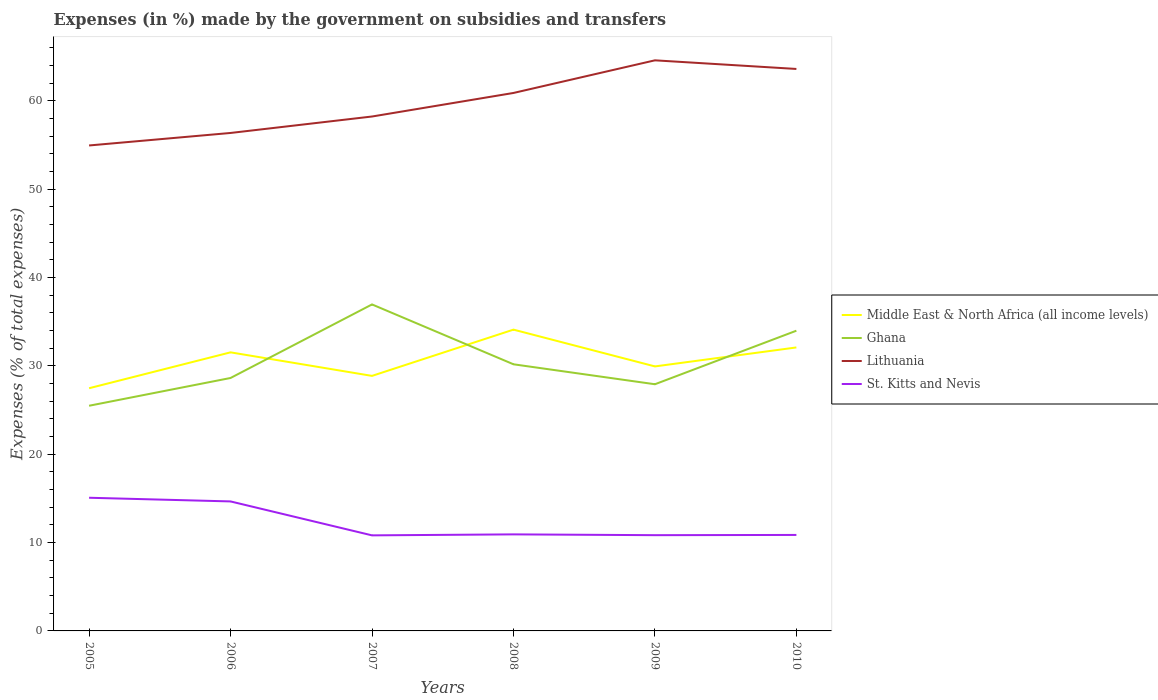Does the line corresponding to Lithuania intersect with the line corresponding to St. Kitts and Nevis?
Make the answer very short. No. Across all years, what is the maximum percentage of expenses made by the government on subsidies and transfers in St. Kitts and Nevis?
Keep it short and to the point. 10.82. What is the total percentage of expenses made by the government on subsidies and transfers in Middle East & North Africa (all income levels) in the graph?
Provide a short and direct response. -4.62. What is the difference between the highest and the second highest percentage of expenses made by the government on subsidies and transfers in Lithuania?
Your answer should be compact. 9.64. What is the difference between the highest and the lowest percentage of expenses made by the government on subsidies and transfers in Ghana?
Ensure brevity in your answer.  2. Is the percentage of expenses made by the government on subsidies and transfers in Middle East & North Africa (all income levels) strictly greater than the percentage of expenses made by the government on subsidies and transfers in Ghana over the years?
Provide a short and direct response. No. How many years are there in the graph?
Provide a succinct answer. 6. What is the difference between two consecutive major ticks on the Y-axis?
Your answer should be compact. 10. Does the graph contain any zero values?
Provide a succinct answer. No. Where does the legend appear in the graph?
Provide a succinct answer. Center right. What is the title of the graph?
Ensure brevity in your answer.  Expenses (in %) made by the government on subsidies and transfers. What is the label or title of the Y-axis?
Offer a terse response. Expenses (% of total expenses). What is the Expenses (% of total expenses) of Middle East & North Africa (all income levels) in 2005?
Your answer should be very brief. 27.47. What is the Expenses (% of total expenses) in Ghana in 2005?
Offer a terse response. 25.49. What is the Expenses (% of total expenses) in Lithuania in 2005?
Your response must be concise. 54.96. What is the Expenses (% of total expenses) of St. Kitts and Nevis in 2005?
Provide a short and direct response. 15.08. What is the Expenses (% of total expenses) in Middle East & North Africa (all income levels) in 2006?
Provide a short and direct response. 31.54. What is the Expenses (% of total expenses) of Ghana in 2006?
Your answer should be very brief. 28.63. What is the Expenses (% of total expenses) in Lithuania in 2006?
Keep it short and to the point. 56.37. What is the Expenses (% of total expenses) in St. Kitts and Nevis in 2006?
Keep it short and to the point. 14.66. What is the Expenses (% of total expenses) of Middle East & North Africa (all income levels) in 2007?
Your answer should be very brief. 28.87. What is the Expenses (% of total expenses) in Ghana in 2007?
Ensure brevity in your answer.  36.96. What is the Expenses (% of total expenses) in Lithuania in 2007?
Offer a very short reply. 58.23. What is the Expenses (% of total expenses) in St. Kitts and Nevis in 2007?
Provide a short and direct response. 10.82. What is the Expenses (% of total expenses) in Middle East & North Africa (all income levels) in 2008?
Your answer should be very brief. 34.11. What is the Expenses (% of total expenses) in Ghana in 2008?
Offer a terse response. 30.18. What is the Expenses (% of total expenses) in Lithuania in 2008?
Your answer should be very brief. 60.9. What is the Expenses (% of total expenses) in St. Kitts and Nevis in 2008?
Make the answer very short. 10.93. What is the Expenses (% of total expenses) in Middle East & North Africa (all income levels) in 2009?
Your answer should be very brief. 29.94. What is the Expenses (% of total expenses) of Ghana in 2009?
Ensure brevity in your answer.  27.92. What is the Expenses (% of total expenses) in Lithuania in 2009?
Your answer should be very brief. 64.59. What is the Expenses (% of total expenses) in St. Kitts and Nevis in 2009?
Offer a very short reply. 10.84. What is the Expenses (% of total expenses) of Middle East & North Africa (all income levels) in 2010?
Provide a succinct answer. 32.09. What is the Expenses (% of total expenses) in Ghana in 2010?
Provide a short and direct response. 33.99. What is the Expenses (% of total expenses) of Lithuania in 2010?
Offer a terse response. 63.62. What is the Expenses (% of total expenses) of St. Kitts and Nevis in 2010?
Give a very brief answer. 10.87. Across all years, what is the maximum Expenses (% of total expenses) in Middle East & North Africa (all income levels)?
Make the answer very short. 34.11. Across all years, what is the maximum Expenses (% of total expenses) of Ghana?
Your answer should be compact. 36.96. Across all years, what is the maximum Expenses (% of total expenses) of Lithuania?
Your response must be concise. 64.59. Across all years, what is the maximum Expenses (% of total expenses) of St. Kitts and Nevis?
Your answer should be very brief. 15.08. Across all years, what is the minimum Expenses (% of total expenses) of Middle East & North Africa (all income levels)?
Your response must be concise. 27.47. Across all years, what is the minimum Expenses (% of total expenses) in Ghana?
Give a very brief answer. 25.49. Across all years, what is the minimum Expenses (% of total expenses) of Lithuania?
Ensure brevity in your answer.  54.96. Across all years, what is the minimum Expenses (% of total expenses) of St. Kitts and Nevis?
Your answer should be compact. 10.82. What is the total Expenses (% of total expenses) in Middle East & North Africa (all income levels) in the graph?
Provide a succinct answer. 184.02. What is the total Expenses (% of total expenses) in Ghana in the graph?
Ensure brevity in your answer.  183.18. What is the total Expenses (% of total expenses) of Lithuania in the graph?
Your response must be concise. 358.67. What is the total Expenses (% of total expenses) of St. Kitts and Nevis in the graph?
Provide a succinct answer. 73.19. What is the difference between the Expenses (% of total expenses) of Middle East & North Africa (all income levels) in 2005 and that in 2006?
Keep it short and to the point. -4.06. What is the difference between the Expenses (% of total expenses) in Ghana in 2005 and that in 2006?
Offer a very short reply. -3.14. What is the difference between the Expenses (% of total expenses) of Lithuania in 2005 and that in 2006?
Make the answer very short. -1.42. What is the difference between the Expenses (% of total expenses) in St. Kitts and Nevis in 2005 and that in 2006?
Give a very brief answer. 0.42. What is the difference between the Expenses (% of total expenses) of Middle East & North Africa (all income levels) in 2005 and that in 2007?
Offer a very short reply. -1.4. What is the difference between the Expenses (% of total expenses) in Ghana in 2005 and that in 2007?
Keep it short and to the point. -11.47. What is the difference between the Expenses (% of total expenses) in Lithuania in 2005 and that in 2007?
Provide a succinct answer. -3.28. What is the difference between the Expenses (% of total expenses) of St. Kitts and Nevis in 2005 and that in 2007?
Ensure brevity in your answer.  4.26. What is the difference between the Expenses (% of total expenses) of Middle East & North Africa (all income levels) in 2005 and that in 2008?
Ensure brevity in your answer.  -6.63. What is the difference between the Expenses (% of total expenses) of Ghana in 2005 and that in 2008?
Offer a very short reply. -4.69. What is the difference between the Expenses (% of total expenses) in Lithuania in 2005 and that in 2008?
Your response must be concise. -5.94. What is the difference between the Expenses (% of total expenses) in St. Kitts and Nevis in 2005 and that in 2008?
Your response must be concise. 4.15. What is the difference between the Expenses (% of total expenses) in Middle East & North Africa (all income levels) in 2005 and that in 2009?
Ensure brevity in your answer.  -2.47. What is the difference between the Expenses (% of total expenses) of Ghana in 2005 and that in 2009?
Keep it short and to the point. -2.43. What is the difference between the Expenses (% of total expenses) of Lithuania in 2005 and that in 2009?
Ensure brevity in your answer.  -9.64. What is the difference between the Expenses (% of total expenses) of St. Kitts and Nevis in 2005 and that in 2009?
Give a very brief answer. 4.24. What is the difference between the Expenses (% of total expenses) of Middle East & North Africa (all income levels) in 2005 and that in 2010?
Keep it short and to the point. -4.62. What is the difference between the Expenses (% of total expenses) of Ghana in 2005 and that in 2010?
Give a very brief answer. -8.5. What is the difference between the Expenses (% of total expenses) in Lithuania in 2005 and that in 2010?
Keep it short and to the point. -8.66. What is the difference between the Expenses (% of total expenses) in St. Kitts and Nevis in 2005 and that in 2010?
Provide a succinct answer. 4.21. What is the difference between the Expenses (% of total expenses) of Middle East & North Africa (all income levels) in 2006 and that in 2007?
Offer a terse response. 2.67. What is the difference between the Expenses (% of total expenses) in Ghana in 2006 and that in 2007?
Give a very brief answer. -8.33. What is the difference between the Expenses (% of total expenses) of Lithuania in 2006 and that in 2007?
Ensure brevity in your answer.  -1.86. What is the difference between the Expenses (% of total expenses) of St. Kitts and Nevis in 2006 and that in 2007?
Your response must be concise. 3.84. What is the difference between the Expenses (% of total expenses) in Middle East & North Africa (all income levels) in 2006 and that in 2008?
Ensure brevity in your answer.  -2.57. What is the difference between the Expenses (% of total expenses) of Ghana in 2006 and that in 2008?
Ensure brevity in your answer.  -1.55. What is the difference between the Expenses (% of total expenses) of Lithuania in 2006 and that in 2008?
Keep it short and to the point. -4.53. What is the difference between the Expenses (% of total expenses) in St. Kitts and Nevis in 2006 and that in 2008?
Your response must be concise. 3.73. What is the difference between the Expenses (% of total expenses) of Middle East & North Africa (all income levels) in 2006 and that in 2009?
Provide a short and direct response. 1.59. What is the difference between the Expenses (% of total expenses) in Ghana in 2006 and that in 2009?
Keep it short and to the point. 0.71. What is the difference between the Expenses (% of total expenses) in Lithuania in 2006 and that in 2009?
Offer a terse response. -8.22. What is the difference between the Expenses (% of total expenses) of St. Kitts and Nevis in 2006 and that in 2009?
Ensure brevity in your answer.  3.82. What is the difference between the Expenses (% of total expenses) of Middle East & North Africa (all income levels) in 2006 and that in 2010?
Provide a short and direct response. -0.56. What is the difference between the Expenses (% of total expenses) in Ghana in 2006 and that in 2010?
Your answer should be very brief. -5.35. What is the difference between the Expenses (% of total expenses) of Lithuania in 2006 and that in 2010?
Your answer should be compact. -7.25. What is the difference between the Expenses (% of total expenses) of St. Kitts and Nevis in 2006 and that in 2010?
Your response must be concise. 3.79. What is the difference between the Expenses (% of total expenses) in Middle East & North Africa (all income levels) in 2007 and that in 2008?
Offer a terse response. -5.24. What is the difference between the Expenses (% of total expenses) in Ghana in 2007 and that in 2008?
Give a very brief answer. 6.78. What is the difference between the Expenses (% of total expenses) of Lithuania in 2007 and that in 2008?
Ensure brevity in your answer.  -2.67. What is the difference between the Expenses (% of total expenses) of St. Kitts and Nevis in 2007 and that in 2008?
Make the answer very short. -0.11. What is the difference between the Expenses (% of total expenses) of Middle East & North Africa (all income levels) in 2007 and that in 2009?
Your answer should be very brief. -1.07. What is the difference between the Expenses (% of total expenses) of Ghana in 2007 and that in 2009?
Provide a short and direct response. 9.04. What is the difference between the Expenses (% of total expenses) of Lithuania in 2007 and that in 2009?
Ensure brevity in your answer.  -6.36. What is the difference between the Expenses (% of total expenses) of St. Kitts and Nevis in 2007 and that in 2009?
Make the answer very short. -0.02. What is the difference between the Expenses (% of total expenses) in Middle East & North Africa (all income levels) in 2007 and that in 2010?
Provide a succinct answer. -3.22. What is the difference between the Expenses (% of total expenses) of Ghana in 2007 and that in 2010?
Provide a short and direct response. 2.97. What is the difference between the Expenses (% of total expenses) in Lithuania in 2007 and that in 2010?
Your response must be concise. -5.38. What is the difference between the Expenses (% of total expenses) of St. Kitts and Nevis in 2007 and that in 2010?
Ensure brevity in your answer.  -0.05. What is the difference between the Expenses (% of total expenses) in Middle East & North Africa (all income levels) in 2008 and that in 2009?
Ensure brevity in your answer.  4.16. What is the difference between the Expenses (% of total expenses) of Ghana in 2008 and that in 2009?
Your answer should be compact. 2.26. What is the difference between the Expenses (% of total expenses) of Lithuania in 2008 and that in 2009?
Offer a very short reply. -3.69. What is the difference between the Expenses (% of total expenses) of St. Kitts and Nevis in 2008 and that in 2009?
Your response must be concise. 0.09. What is the difference between the Expenses (% of total expenses) of Middle East & North Africa (all income levels) in 2008 and that in 2010?
Your response must be concise. 2.02. What is the difference between the Expenses (% of total expenses) of Ghana in 2008 and that in 2010?
Provide a succinct answer. -3.8. What is the difference between the Expenses (% of total expenses) of Lithuania in 2008 and that in 2010?
Your answer should be very brief. -2.72. What is the difference between the Expenses (% of total expenses) in St. Kitts and Nevis in 2008 and that in 2010?
Your answer should be very brief. 0.06. What is the difference between the Expenses (% of total expenses) of Middle East & North Africa (all income levels) in 2009 and that in 2010?
Offer a terse response. -2.15. What is the difference between the Expenses (% of total expenses) of Ghana in 2009 and that in 2010?
Ensure brevity in your answer.  -6.06. What is the difference between the Expenses (% of total expenses) in Lithuania in 2009 and that in 2010?
Your response must be concise. 0.98. What is the difference between the Expenses (% of total expenses) of St. Kitts and Nevis in 2009 and that in 2010?
Give a very brief answer. -0.03. What is the difference between the Expenses (% of total expenses) of Middle East & North Africa (all income levels) in 2005 and the Expenses (% of total expenses) of Ghana in 2006?
Your answer should be compact. -1.16. What is the difference between the Expenses (% of total expenses) of Middle East & North Africa (all income levels) in 2005 and the Expenses (% of total expenses) of Lithuania in 2006?
Offer a very short reply. -28.9. What is the difference between the Expenses (% of total expenses) of Middle East & North Africa (all income levels) in 2005 and the Expenses (% of total expenses) of St. Kitts and Nevis in 2006?
Provide a succinct answer. 12.82. What is the difference between the Expenses (% of total expenses) of Ghana in 2005 and the Expenses (% of total expenses) of Lithuania in 2006?
Offer a very short reply. -30.88. What is the difference between the Expenses (% of total expenses) of Ghana in 2005 and the Expenses (% of total expenses) of St. Kitts and Nevis in 2006?
Your response must be concise. 10.83. What is the difference between the Expenses (% of total expenses) in Lithuania in 2005 and the Expenses (% of total expenses) in St. Kitts and Nevis in 2006?
Provide a succinct answer. 40.3. What is the difference between the Expenses (% of total expenses) in Middle East & North Africa (all income levels) in 2005 and the Expenses (% of total expenses) in Ghana in 2007?
Offer a terse response. -9.49. What is the difference between the Expenses (% of total expenses) in Middle East & North Africa (all income levels) in 2005 and the Expenses (% of total expenses) in Lithuania in 2007?
Your response must be concise. -30.76. What is the difference between the Expenses (% of total expenses) in Middle East & North Africa (all income levels) in 2005 and the Expenses (% of total expenses) in St. Kitts and Nevis in 2007?
Ensure brevity in your answer.  16.66. What is the difference between the Expenses (% of total expenses) in Ghana in 2005 and the Expenses (% of total expenses) in Lithuania in 2007?
Keep it short and to the point. -32.74. What is the difference between the Expenses (% of total expenses) in Ghana in 2005 and the Expenses (% of total expenses) in St. Kitts and Nevis in 2007?
Your answer should be very brief. 14.67. What is the difference between the Expenses (% of total expenses) of Lithuania in 2005 and the Expenses (% of total expenses) of St. Kitts and Nevis in 2007?
Offer a very short reply. 44.14. What is the difference between the Expenses (% of total expenses) in Middle East & North Africa (all income levels) in 2005 and the Expenses (% of total expenses) in Ghana in 2008?
Make the answer very short. -2.71. What is the difference between the Expenses (% of total expenses) in Middle East & North Africa (all income levels) in 2005 and the Expenses (% of total expenses) in Lithuania in 2008?
Offer a very short reply. -33.43. What is the difference between the Expenses (% of total expenses) of Middle East & North Africa (all income levels) in 2005 and the Expenses (% of total expenses) of St. Kitts and Nevis in 2008?
Offer a very short reply. 16.55. What is the difference between the Expenses (% of total expenses) of Ghana in 2005 and the Expenses (% of total expenses) of Lithuania in 2008?
Keep it short and to the point. -35.41. What is the difference between the Expenses (% of total expenses) in Ghana in 2005 and the Expenses (% of total expenses) in St. Kitts and Nevis in 2008?
Your answer should be very brief. 14.56. What is the difference between the Expenses (% of total expenses) of Lithuania in 2005 and the Expenses (% of total expenses) of St. Kitts and Nevis in 2008?
Your answer should be compact. 44.03. What is the difference between the Expenses (% of total expenses) of Middle East & North Africa (all income levels) in 2005 and the Expenses (% of total expenses) of Ghana in 2009?
Keep it short and to the point. -0.45. What is the difference between the Expenses (% of total expenses) of Middle East & North Africa (all income levels) in 2005 and the Expenses (% of total expenses) of Lithuania in 2009?
Your answer should be compact. -37.12. What is the difference between the Expenses (% of total expenses) of Middle East & North Africa (all income levels) in 2005 and the Expenses (% of total expenses) of St. Kitts and Nevis in 2009?
Ensure brevity in your answer.  16.63. What is the difference between the Expenses (% of total expenses) of Ghana in 2005 and the Expenses (% of total expenses) of Lithuania in 2009?
Offer a very short reply. -39.1. What is the difference between the Expenses (% of total expenses) of Ghana in 2005 and the Expenses (% of total expenses) of St. Kitts and Nevis in 2009?
Provide a short and direct response. 14.65. What is the difference between the Expenses (% of total expenses) in Lithuania in 2005 and the Expenses (% of total expenses) in St. Kitts and Nevis in 2009?
Provide a short and direct response. 44.12. What is the difference between the Expenses (% of total expenses) of Middle East & North Africa (all income levels) in 2005 and the Expenses (% of total expenses) of Ghana in 2010?
Provide a short and direct response. -6.51. What is the difference between the Expenses (% of total expenses) in Middle East & North Africa (all income levels) in 2005 and the Expenses (% of total expenses) in Lithuania in 2010?
Ensure brevity in your answer.  -36.14. What is the difference between the Expenses (% of total expenses) of Middle East & North Africa (all income levels) in 2005 and the Expenses (% of total expenses) of St. Kitts and Nevis in 2010?
Provide a succinct answer. 16.61. What is the difference between the Expenses (% of total expenses) in Ghana in 2005 and the Expenses (% of total expenses) in Lithuania in 2010?
Offer a very short reply. -38.13. What is the difference between the Expenses (% of total expenses) in Ghana in 2005 and the Expenses (% of total expenses) in St. Kitts and Nevis in 2010?
Ensure brevity in your answer.  14.63. What is the difference between the Expenses (% of total expenses) of Lithuania in 2005 and the Expenses (% of total expenses) of St. Kitts and Nevis in 2010?
Your response must be concise. 44.09. What is the difference between the Expenses (% of total expenses) of Middle East & North Africa (all income levels) in 2006 and the Expenses (% of total expenses) of Ghana in 2007?
Your answer should be compact. -5.42. What is the difference between the Expenses (% of total expenses) of Middle East & North Africa (all income levels) in 2006 and the Expenses (% of total expenses) of Lithuania in 2007?
Ensure brevity in your answer.  -26.7. What is the difference between the Expenses (% of total expenses) in Middle East & North Africa (all income levels) in 2006 and the Expenses (% of total expenses) in St. Kitts and Nevis in 2007?
Your response must be concise. 20.72. What is the difference between the Expenses (% of total expenses) of Ghana in 2006 and the Expenses (% of total expenses) of Lithuania in 2007?
Offer a terse response. -29.6. What is the difference between the Expenses (% of total expenses) of Ghana in 2006 and the Expenses (% of total expenses) of St. Kitts and Nevis in 2007?
Provide a short and direct response. 17.82. What is the difference between the Expenses (% of total expenses) of Lithuania in 2006 and the Expenses (% of total expenses) of St. Kitts and Nevis in 2007?
Your response must be concise. 45.55. What is the difference between the Expenses (% of total expenses) of Middle East & North Africa (all income levels) in 2006 and the Expenses (% of total expenses) of Ghana in 2008?
Ensure brevity in your answer.  1.35. What is the difference between the Expenses (% of total expenses) of Middle East & North Africa (all income levels) in 2006 and the Expenses (% of total expenses) of Lithuania in 2008?
Provide a succinct answer. -29.36. What is the difference between the Expenses (% of total expenses) in Middle East & North Africa (all income levels) in 2006 and the Expenses (% of total expenses) in St. Kitts and Nevis in 2008?
Ensure brevity in your answer.  20.61. What is the difference between the Expenses (% of total expenses) of Ghana in 2006 and the Expenses (% of total expenses) of Lithuania in 2008?
Make the answer very short. -32.27. What is the difference between the Expenses (% of total expenses) in Ghana in 2006 and the Expenses (% of total expenses) in St. Kitts and Nevis in 2008?
Offer a very short reply. 17.71. What is the difference between the Expenses (% of total expenses) of Lithuania in 2006 and the Expenses (% of total expenses) of St. Kitts and Nevis in 2008?
Your answer should be compact. 45.44. What is the difference between the Expenses (% of total expenses) in Middle East & North Africa (all income levels) in 2006 and the Expenses (% of total expenses) in Ghana in 2009?
Provide a succinct answer. 3.61. What is the difference between the Expenses (% of total expenses) in Middle East & North Africa (all income levels) in 2006 and the Expenses (% of total expenses) in Lithuania in 2009?
Offer a very short reply. -33.06. What is the difference between the Expenses (% of total expenses) of Middle East & North Africa (all income levels) in 2006 and the Expenses (% of total expenses) of St. Kitts and Nevis in 2009?
Keep it short and to the point. 20.7. What is the difference between the Expenses (% of total expenses) in Ghana in 2006 and the Expenses (% of total expenses) in Lithuania in 2009?
Offer a terse response. -35.96. What is the difference between the Expenses (% of total expenses) of Ghana in 2006 and the Expenses (% of total expenses) of St. Kitts and Nevis in 2009?
Make the answer very short. 17.79. What is the difference between the Expenses (% of total expenses) of Lithuania in 2006 and the Expenses (% of total expenses) of St. Kitts and Nevis in 2009?
Provide a short and direct response. 45.53. What is the difference between the Expenses (% of total expenses) of Middle East & North Africa (all income levels) in 2006 and the Expenses (% of total expenses) of Ghana in 2010?
Offer a very short reply. -2.45. What is the difference between the Expenses (% of total expenses) of Middle East & North Africa (all income levels) in 2006 and the Expenses (% of total expenses) of Lithuania in 2010?
Offer a terse response. -32.08. What is the difference between the Expenses (% of total expenses) in Middle East & North Africa (all income levels) in 2006 and the Expenses (% of total expenses) in St. Kitts and Nevis in 2010?
Provide a short and direct response. 20.67. What is the difference between the Expenses (% of total expenses) of Ghana in 2006 and the Expenses (% of total expenses) of Lithuania in 2010?
Offer a very short reply. -34.98. What is the difference between the Expenses (% of total expenses) of Ghana in 2006 and the Expenses (% of total expenses) of St. Kitts and Nevis in 2010?
Provide a short and direct response. 17.77. What is the difference between the Expenses (% of total expenses) in Lithuania in 2006 and the Expenses (% of total expenses) in St. Kitts and Nevis in 2010?
Keep it short and to the point. 45.51. What is the difference between the Expenses (% of total expenses) in Middle East & North Africa (all income levels) in 2007 and the Expenses (% of total expenses) in Ghana in 2008?
Your answer should be very brief. -1.31. What is the difference between the Expenses (% of total expenses) of Middle East & North Africa (all income levels) in 2007 and the Expenses (% of total expenses) of Lithuania in 2008?
Your answer should be very brief. -32.03. What is the difference between the Expenses (% of total expenses) in Middle East & North Africa (all income levels) in 2007 and the Expenses (% of total expenses) in St. Kitts and Nevis in 2008?
Your answer should be very brief. 17.94. What is the difference between the Expenses (% of total expenses) of Ghana in 2007 and the Expenses (% of total expenses) of Lithuania in 2008?
Provide a short and direct response. -23.94. What is the difference between the Expenses (% of total expenses) of Ghana in 2007 and the Expenses (% of total expenses) of St. Kitts and Nevis in 2008?
Provide a short and direct response. 26.03. What is the difference between the Expenses (% of total expenses) of Lithuania in 2007 and the Expenses (% of total expenses) of St. Kitts and Nevis in 2008?
Keep it short and to the point. 47.31. What is the difference between the Expenses (% of total expenses) of Middle East & North Africa (all income levels) in 2007 and the Expenses (% of total expenses) of Ghana in 2009?
Your answer should be compact. 0.95. What is the difference between the Expenses (% of total expenses) in Middle East & North Africa (all income levels) in 2007 and the Expenses (% of total expenses) in Lithuania in 2009?
Provide a succinct answer. -35.72. What is the difference between the Expenses (% of total expenses) of Middle East & North Africa (all income levels) in 2007 and the Expenses (% of total expenses) of St. Kitts and Nevis in 2009?
Your response must be concise. 18.03. What is the difference between the Expenses (% of total expenses) of Ghana in 2007 and the Expenses (% of total expenses) of Lithuania in 2009?
Offer a very short reply. -27.63. What is the difference between the Expenses (% of total expenses) in Ghana in 2007 and the Expenses (% of total expenses) in St. Kitts and Nevis in 2009?
Provide a succinct answer. 26.12. What is the difference between the Expenses (% of total expenses) in Lithuania in 2007 and the Expenses (% of total expenses) in St. Kitts and Nevis in 2009?
Give a very brief answer. 47.39. What is the difference between the Expenses (% of total expenses) of Middle East & North Africa (all income levels) in 2007 and the Expenses (% of total expenses) of Ghana in 2010?
Your answer should be compact. -5.12. What is the difference between the Expenses (% of total expenses) of Middle East & North Africa (all income levels) in 2007 and the Expenses (% of total expenses) of Lithuania in 2010?
Ensure brevity in your answer.  -34.75. What is the difference between the Expenses (% of total expenses) in Middle East & North Africa (all income levels) in 2007 and the Expenses (% of total expenses) in St. Kitts and Nevis in 2010?
Provide a succinct answer. 18. What is the difference between the Expenses (% of total expenses) of Ghana in 2007 and the Expenses (% of total expenses) of Lithuania in 2010?
Your answer should be compact. -26.66. What is the difference between the Expenses (% of total expenses) in Ghana in 2007 and the Expenses (% of total expenses) in St. Kitts and Nevis in 2010?
Give a very brief answer. 26.09. What is the difference between the Expenses (% of total expenses) of Lithuania in 2007 and the Expenses (% of total expenses) of St. Kitts and Nevis in 2010?
Ensure brevity in your answer.  47.37. What is the difference between the Expenses (% of total expenses) of Middle East & North Africa (all income levels) in 2008 and the Expenses (% of total expenses) of Ghana in 2009?
Keep it short and to the point. 6.18. What is the difference between the Expenses (% of total expenses) in Middle East & North Africa (all income levels) in 2008 and the Expenses (% of total expenses) in Lithuania in 2009?
Provide a succinct answer. -30.49. What is the difference between the Expenses (% of total expenses) of Middle East & North Africa (all income levels) in 2008 and the Expenses (% of total expenses) of St. Kitts and Nevis in 2009?
Your answer should be compact. 23.27. What is the difference between the Expenses (% of total expenses) of Ghana in 2008 and the Expenses (% of total expenses) of Lithuania in 2009?
Ensure brevity in your answer.  -34.41. What is the difference between the Expenses (% of total expenses) in Ghana in 2008 and the Expenses (% of total expenses) in St. Kitts and Nevis in 2009?
Provide a succinct answer. 19.34. What is the difference between the Expenses (% of total expenses) of Lithuania in 2008 and the Expenses (% of total expenses) of St. Kitts and Nevis in 2009?
Give a very brief answer. 50.06. What is the difference between the Expenses (% of total expenses) of Middle East & North Africa (all income levels) in 2008 and the Expenses (% of total expenses) of Ghana in 2010?
Offer a very short reply. 0.12. What is the difference between the Expenses (% of total expenses) in Middle East & North Africa (all income levels) in 2008 and the Expenses (% of total expenses) in Lithuania in 2010?
Your answer should be compact. -29.51. What is the difference between the Expenses (% of total expenses) in Middle East & North Africa (all income levels) in 2008 and the Expenses (% of total expenses) in St. Kitts and Nevis in 2010?
Provide a succinct answer. 23.24. What is the difference between the Expenses (% of total expenses) of Ghana in 2008 and the Expenses (% of total expenses) of Lithuania in 2010?
Your answer should be very brief. -33.43. What is the difference between the Expenses (% of total expenses) of Ghana in 2008 and the Expenses (% of total expenses) of St. Kitts and Nevis in 2010?
Offer a terse response. 19.32. What is the difference between the Expenses (% of total expenses) of Lithuania in 2008 and the Expenses (% of total expenses) of St. Kitts and Nevis in 2010?
Ensure brevity in your answer.  50.03. What is the difference between the Expenses (% of total expenses) in Middle East & North Africa (all income levels) in 2009 and the Expenses (% of total expenses) in Ghana in 2010?
Provide a short and direct response. -4.04. What is the difference between the Expenses (% of total expenses) of Middle East & North Africa (all income levels) in 2009 and the Expenses (% of total expenses) of Lithuania in 2010?
Offer a terse response. -33.67. What is the difference between the Expenses (% of total expenses) in Middle East & North Africa (all income levels) in 2009 and the Expenses (% of total expenses) in St. Kitts and Nevis in 2010?
Your answer should be very brief. 19.08. What is the difference between the Expenses (% of total expenses) of Ghana in 2009 and the Expenses (% of total expenses) of Lithuania in 2010?
Your answer should be compact. -35.69. What is the difference between the Expenses (% of total expenses) of Ghana in 2009 and the Expenses (% of total expenses) of St. Kitts and Nevis in 2010?
Ensure brevity in your answer.  17.06. What is the difference between the Expenses (% of total expenses) in Lithuania in 2009 and the Expenses (% of total expenses) in St. Kitts and Nevis in 2010?
Provide a succinct answer. 53.73. What is the average Expenses (% of total expenses) of Middle East & North Africa (all income levels) per year?
Your response must be concise. 30.67. What is the average Expenses (% of total expenses) of Ghana per year?
Provide a succinct answer. 30.53. What is the average Expenses (% of total expenses) of Lithuania per year?
Make the answer very short. 59.78. What is the average Expenses (% of total expenses) in St. Kitts and Nevis per year?
Your response must be concise. 12.2. In the year 2005, what is the difference between the Expenses (% of total expenses) of Middle East & North Africa (all income levels) and Expenses (% of total expenses) of Ghana?
Your answer should be compact. 1.98. In the year 2005, what is the difference between the Expenses (% of total expenses) in Middle East & North Africa (all income levels) and Expenses (% of total expenses) in Lithuania?
Your answer should be compact. -27.48. In the year 2005, what is the difference between the Expenses (% of total expenses) in Middle East & North Africa (all income levels) and Expenses (% of total expenses) in St. Kitts and Nevis?
Keep it short and to the point. 12.4. In the year 2005, what is the difference between the Expenses (% of total expenses) of Ghana and Expenses (% of total expenses) of Lithuania?
Your answer should be very brief. -29.46. In the year 2005, what is the difference between the Expenses (% of total expenses) in Ghana and Expenses (% of total expenses) in St. Kitts and Nevis?
Your answer should be compact. 10.42. In the year 2005, what is the difference between the Expenses (% of total expenses) of Lithuania and Expenses (% of total expenses) of St. Kitts and Nevis?
Your answer should be very brief. 39.88. In the year 2006, what is the difference between the Expenses (% of total expenses) of Middle East & North Africa (all income levels) and Expenses (% of total expenses) of Ghana?
Offer a very short reply. 2.9. In the year 2006, what is the difference between the Expenses (% of total expenses) in Middle East & North Africa (all income levels) and Expenses (% of total expenses) in Lithuania?
Provide a succinct answer. -24.83. In the year 2006, what is the difference between the Expenses (% of total expenses) in Middle East & North Africa (all income levels) and Expenses (% of total expenses) in St. Kitts and Nevis?
Offer a terse response. 16.88. In the year 2006, what is the difference between the Expenses (% of total expenses) of Ghana and Expenses (% of total expenses) of Lithuania?
Your answer should be compact. -27.74. In the year 2006, what is the difference between the Expenses (% of total expenses) in Ghana and Expenses (% of total expenses) in St. Kitts and Nevis?
Give a very brief answer. 13.97. In the year 2006, what is the difference between the Expenses (% of total expenses) of Lithuania and Expenses (% of total expenses) of St. Kitts and Nevis?
Provide a succinct answer. 41.71. In the year 2007, what is the difference between the Expenses (% of total expenses) of Middle East & North Africa (all income levels) and Expenses (% of total expenses) of Ghana?
Provide a short and direct response. -8.09. In the year 2007, what is the difference between the Expenses (% of total expenses) in Middle East & North Africa (all income levels) and Expenses (% of total expenses) in Lithuania?
Give a very brief answer. -29.36. In the year 2007, what is the difference between the Expenses (% of total expenses) of Middle East & North Africa (all income levels) and Expenses (% of total expenses) of St. Kitts and Nevis?
Your answer should be compact. 18.05. In the year 2007, what is the difference between the Expenses (% of total expenses) in Ghana and Expenses (% of total expenses) in Lithuania?
Provide a succinct answer. -21.27. In the year 2007, what is the difference between the Expenses (% of total expenses) in Ghana and Expenses (% of total expenses) in St. Kitts and Nevis?
Keep it short and to the point. 26.14. In the year 2007, what is the difference between the Expenses (% of total expenses) of Lithuania and Expenses (% of total expenses) of St. Kitts and Nevis?
Ensure brevity in your answer.  47.42. In the year 2008, what is the difference between the Expenses (% of total expenses) of Middle East & North Africa (all income levels) and Expenses (% of total expenses) of Ghana?
Offer a very short reply. 3.92. In the year 2008, what is the difference between the Expenses (% of total expenses) of Middle East & North Africa (all income levels) and Expenses (% of total expenses) of Lithuania?
Your answer should be very brief. -26.79. In the year 2008, what is the difference between the Expenses (% of total expenses) of Middle East & North Africa (all income levels) and Expenses (% of total expenses) of St. Kitts and Nevis?
Your answer should be very brief. 23.18. In the year 2008, what is the difference between the Expenses (% of total expenses) in Ghana and Expenses (% of total expenses) in Lithuania?
Provide a short and direct response. -30.72. In the year 2008, what is the difference between the Expenses (% of total expenses) in Ghana and Expenses (% of total expenses) in St. Kitts and Nevis?
Your response must be concise. 19.26. In the year 2008, what is the difference between the Expenses (% of total expenses) of Lithuania and Expenses (% of total expenses) of St. Kitts and Nevis?
Offer a very short reply. 49.97. In the year 2009, what is the difference between the Expenses (% of total expenses) in Middle East & North Africa (all income levels) and Expenses (% of total expenses) in Ghana?
Your answer should be compact. 2.02. In the year 2009, what is the difference between the Expenses (% of total expenses) in Middle East & North Africa (all income levels) and Expenses (% of total expenses) in Lithuania?
Ensure brevity in your answer.  -34.65. In the year 2009, what is the difference between the Expenses (% of total expenses) of Middle East & North Africa (all income levels) and Expenses (% of total expenses) of St. Kitts and Nevis?
Keep it short and to the point. 19.1. In the year 2009, what is the difference between the Expenses (% of total expenses) in Ghana and Expenses (% of total expenses) in Lithuania?
Offer a terse response. -36.67. In the year 2009, what is the difference between the Expenses (% of total expenses) in Ghana and Expenses (% of total expenses) in St. Kitts and Nevis?
Make the answer very short. 17.08. In the year 2009, what is the difference between the Expenses (% of total expenses) in Lithuania and Expenses (% of total expenses) in St. Kitts and Nevis?
Provide a succinct answer. 53.75. In the year 2010, what is the difference between the Expenses (% of total expenses) of Middle East & North Africa (all income levels) and Expenses (% of total expenses) of Ghana?
Your answer should be very brief. -1.89. In the year 2010, what is the difference between the Expenses (% of total expenses) of Middle East & North Africa (all income levels) and Expenses (% of total expenses) of Lithuania?
Your response must be concise. -31.53. In the year 2010, what is the difference between the Expenses (% of total expenses) in Middle East & North Africa (all income levels) and Expenses (% of total expenses) in St. Kitts and Nevis?
Your response must be concise. 21.23. In the year 2010, what is the difference between the Expenses (% of total expenses) of Ghana and Expenses (% of total expenses) of Lithuania?
Your answer should be compact. -29.63. In the year 2010, what is the difference between the Expenses (% of total expenses) of Ghana and Expenses (% of total expenses) of St. Kitts and Nevis?
Provide a short and direct response. 23.12. In the year 2010, what is the difference between the Expenses (% of total expenses) in Lithuania and Expenses (% of total expenses) in St. Kitts and Nevis?
Provide a succinct answer. 52.75. What is the ratio of the Expenses (% of total expenses) of Middle East & North Africa (all income levels) in 2005 to that in 2006?
Your response must be concise. 0.87. What is the ratio of the Expenses (% of total expenses) of Ghana in 2005 to that in 2006?
Ensure brevity in your answer.  0.89. What is the ratio of the Expenses (% of total expenses) in Lithuania in 2005 to that in 2006?
Ensure brevity in your answer.  0.97. What is the ratio of the Expenses (% of total expenses) in St. Kitts and Nevis in 2005 to that in 2006?
Provide a succinct answer. 1.03. What is the ratio of the Expenses (% of total expenses) in Middle East & North Africa (all income levels) in 2005 to that in 2007?
Offer a terse response. 0.95. What is the ratio of the Expenses (% of total expenses) of Ghana in 2005 to that in 2007?
Make the answer very short. 0.69. What is the ratio of the Expenses (% of total expenses) of Lithuania in 2005 to that in 2007?
Ensure brevity in your answer.  0.94. What is the ratio of the Expenses (% of total expenses) in St. Kitts and Nevis in 2005 to that in 2007?
Your response must be concise. 1.39. What is the ratio of the Expenses (% of total expenses) in Middle East & North Africa (all income levels) in 2005 to that in 2008?
Your response must be concise. 0.81. What is the ratio of the Expenses (% of total expenses) of Ghana in 2005 to that in 2008?
Provide a short and direct response. 0.84. What is the ratio of the Expenses (% of total expenses) of Lithuania in 2005 to that in 2008?
Your answer should be very brief. 0.9. What is the ratio of the Expenses (% of total expenses) in St. Kitts and Nevis in 2005 to that in 2008?
Offer a very short reply. 1.38. What is the ratio of the Expenses (% of total expenses) of Middle East & North Africa (all income levels) in 2005 to that in 2009?
Give a very brief answer. 0.92. What is the ratio of the Expenses (% of total expenses) in Ghana in 2005 to that in 2009?
Your response must be concise. 0.91. What is the ratio of the Expenses (% of total expenses) of Lithuania in 2005 to that in 2009?
Ensure brevity in your answer.  0.85. What is the ratio of the Expenses (% of total expenses) in St. Kitts and Nevis in 2005 to that in 2009?
Your answer should be very brief. 1.39. What is the ratio of the Expenses (% of total expenses) of Middle East & North Africa (all income levels) in 2005 to that in 2010?
Offer a very short reply. 0.86. What is the ratio of the Expenses (% of total expenses) of Ghana in 2005 to that in 2010?
Your response must be concise. 0.75. What is the ratio of the Expenses (% of total expenses) in Lithuania in 2005 to that in 2010?
Offer a very short reply. 0.86. What is the ratio of the Expenses (% of total expenses) of St. Kitts and Nevis in 2005 to that in 2010?
Provide a succinct answer. 1.39. What is the ratio of the Expenses (% of total expenses) of Middle East & North Africa (all income levels) in 2006 to that in 2007?
Provide a short and direct response. 1.09. What is the ratio of the Expenses (% of total expenses) of Ghana in 2006 to that in 2007?
Offer a terse response. 0.77. What is the ratio of the Expenses (% of total expenses) of Lithuania in 2006 to that in 2007?
Your answer should be very brief. 0.97. What is the ratio of the Expenses (% of total expenses) of St. Kitts and Nevis in 2006 to that in 2007?
Your answer should be compact. 1.36. What is the ratio of the Expenses (% of total expenses) in Middle East & North Africa (all income levels) in 2006 to that in 2008?
Give a very brief answer. 0.92. What is the ratio of the Expenses (% of total expenses) of Ghana in 2006 to that in 2008?
Offer a terse response. 0.95. What is the ratio of the Expenses (% of total expenses) in Lithuania in 2006 to that in 2008?
Ensure brevity in your answer.  0.93. What is the ratio of the Expenses (% of total expenses) of St. Kitts and Nevis in 2006 to that in 2008?
Make the answer very short. 1.34. What is the ratio of the Expenses (% of total expenses) of Middle East & North Africa (all income levels) in 2006 to that in 2009?
Your answer should be very brief. 1.05. What is the ratio of the Expenses (% of total expenses) in Ghana in 2006 to that in 2009?
Keep it short and to the point. 1.03. What is the ratio of the Expenses (% of total expenses) of Lithuania in 2006 to that in 2009?
Your answer should be very brief. 0.87. What is the ratio of the Expenses (% of total expenses) of St. Kitts and Nevis in 2006 to that in 2009?
Make the answer very short. 1.35. What is the ratio of the Expenses (% of total expenses) in Middle East & North Africa (all income levels) in 2006 to that in 2010?
Provide a succinct answer. 0.98. What is the ratio of the Expenses (% of total expenses) in Ghana in 2006 to that in 2010?
Ensure brevity in your answer.  0.84. What is the ratio of the Expenses (% of total expenses) of Lithuania in 2006 to that in 2010?
Make the answer very short. 0.89. What is the ratio of the Expenses (% of total expenses) of St. Kitts and Nevis in 2006 to that in 2010?
Your answer should be very brief. 1.35. What is the ratio of the Expenses (% of total expenses) of Middle East & North Africa (all income levels) in 2007 to that in 2008?
Provide a succinct answer. 0.85. What is the ratio of the Expenses (% of total expenses) in Ghana in 2007 to that in 2008?
Ensure brevity in your answer.  1.22. What is the ratio of the Expenses (% of total expenses) of Lithuania in 2007 to that in 2008?
Make the answer very short. 0.96. What is the ratio of the Expenses (% of total expenses) in St. Kitts and Nevis in 2007 to that in 2008?
Offer a very short reply. 0.99. What is the ratio of the Expenses (% of total expenses) of Middle East & North Africa (all income levels) in 2007 to that in 2009?
Your answer should be very brief. 0.96. What is the ratio of the Expenses (% of total expenses) of Ghana in 2007 to that in 2009?
Make the answer very short. 1.32. What is the ratio of the Expenses (% of total expenses) in Lithuania in 2007 to that in 2009?
Your answer should be very brief. 0.9. What is the ratio of the Expenses (% of total expenses) of Middle East & North Africa (all income levels) in 2007 to that in 2010?
Offer a very short reply. 0.9. What is the ratio of the Expenses (% of total expenses) of Ghana in 2007 to that in 2010?
Your response must be concise. 1.09. What is the ratio of the Expenses (% of total expenses) in Lithuania in 2007 to that in 2010?
Make the answer very short. 0.92. What is the ratio of the Expenses (% of total expenses) of Middle East & North Africa (all income levels) in 2008 to that in 2009?
Keep it short and to the point. 1.14. What is the ratio of the Expenses (% of total expenses) of Ghana in 2008 to that in 2009?
Provide a succinct answer. 1.08. What is the ratio of the Expenses (% of total expenses) of Lithuania in 2008 to that in 2009?
Make the answer very short. 0.94. What is the ratio of the Expenses (% of total expenses) of St. Kitts and Nevis in 2008 to that in 2009?
Your answer should be very brief. 1.01. What is the ratio of the Expenses (% of total expenses) of Middle East & North Africa (all income levels) in 2008 to that in 2010?
Your response must be concise. 1.06. What is the ratio of the Expenses (% of total expenses) of Ghana in 2008 to that in 2010?
Offer a terse response. 0.89. What is the ratio of the Expenses (% of total expenses) in Lithuania in 2008 to that in 2010?
Give a very brief answer. 0.96. What is the ratio of the Expenses (% of total expenses) of St. Kitts and Nevis in 2008 to that in 2010?
Provide a short and direct response. 1.01. What is the ratio of the Expenses (% of total expenses) in Middle East & North Africa (all income levels) in 2009 to that in 2010?
Your response must be concise. 0.93. What is the ratio of the Expenses (% of total expenses) in Ghana in 2009 to that in 2010?
Keep it short and to the point. 0.82. What is the ratio of the Expenses (% of total expenses) in Lithuania in 2009 to that in 2010?
Make the answer very short. 1.02. What is the ratio of the Expenses (% of total expenses) of St. Kitts and Nevis in 2009 to that in 2010?
Your answer should be compact. 1. What is the difference between the highest and the second highest Expenses (% of total expenses) of Middle East & North Africa (all income levels)?
Give a very brief answer. 2.02. What is the difference between the highest and the second highest Expenses (% of total expenses) in Ghana?
Provide a succinct answer. 2.97. What is the difference between the highest and the second highest Expenses (% of total expenses) of Lithuania?
Ensure brevity in your answer.  0.98. What is the difference between the highest and the second highest Expenses (% of total expenses) in St. Kitts and Nevis?
Provide a short and direct response. 0.42. What is the difference between the highest and the lowest Expenses (% of total expenses) in Middle East & North Africa (all income levels)?
Offer a terse response. 6.63. What is the difference between the highest and the lowest Expenses (% of total expenses) in Ghana?
Ensure brevity in your answer.  11.47. What is the difference between the highest and the lowest Expenses (% of total expenses) of Lithuania?
Keep it short and to the point. 9.64. What is the difference between the highest and the lowest Expenses (% of total expenses) of St. Kitts and Nevis?
Give a very brief answer. 4.26. 